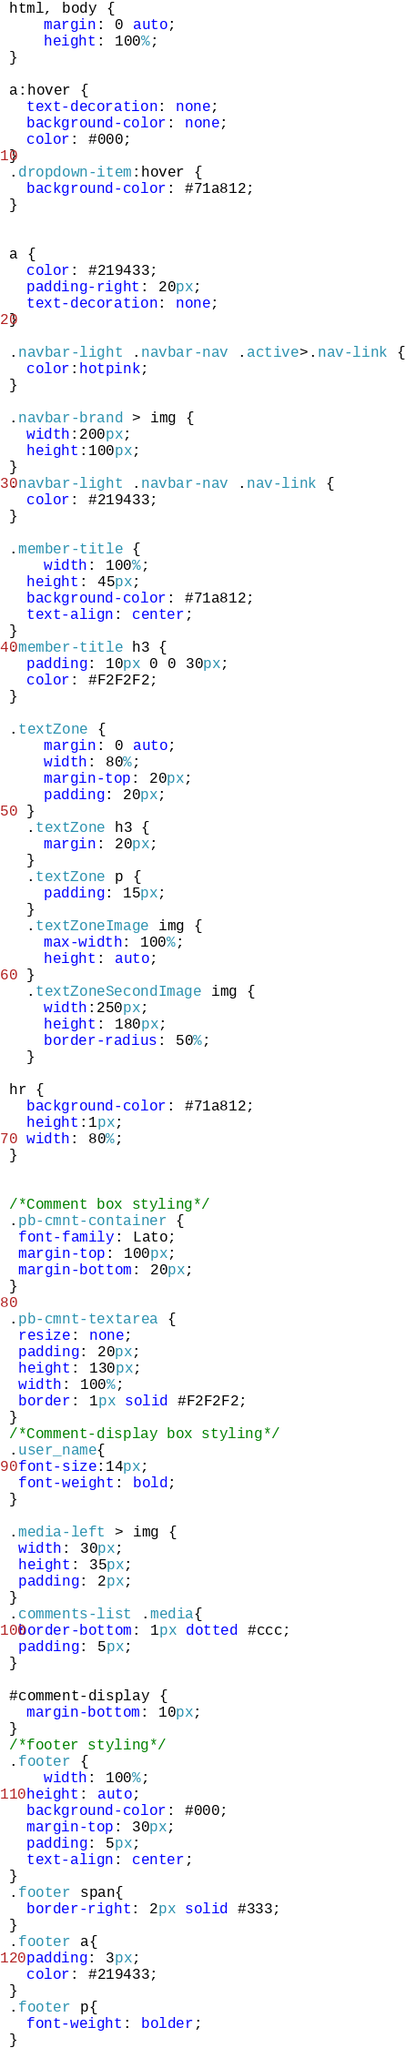Convert code to text. <code><loc_0><loc_0><loc_500><loc_500><_CSS_>

html, body {
    margin: 0 auto;
    height: 100%;
}

a:hover {
  text-decoration: none;
  background-color: none;
  color: #000;
}
.dropdown-item:hover {
  background-color: #71a812;
}


a {
  color: #219433;
  padding-right: 20px;
  text-decoration: none;
}

.navbar-light .navbar-nav .active>.nav-link {
  color:hotpink;
}

.navbar-brand > img {
  width:200px;
  height:100px;
}
.navbar-light .navbar-nav .nav-link {
  color: #219433;
}

.member-title {
	width: 100%;
  height: 45px;
  background-color: #71a812;
  text-align: center;
}
.member-title h3 {
  padding: 10px 0 0 30px;
  color: #F2F2F2;
}

.textZone {
    margin: 0 auto;
    width: 80%;
    margin-top: 20px;
    padding: 20px;
  }
  .textZone h3 {
    margin: 20px;
  }
  .textZone p {
    padding: 15px;
  }
  .textZoneImage img {
    max-width: 100%;
    height: auto;
  }
  .textZoneSecondImage img {
    width:250px;
    height: 180px;
    border-radius: 50%;
  }

hr {
  background-color: #71a812;
  height:1px;
  width: 80%;
}


/*Comment box styling*/
.pb-cmnt-container {
 font-family: Lato;
 margin-top: 100px;
 margin-bottom: 20px;
}

.pb-cmnt-textarea {
 resize: none;
 padding: 20px;
 height: 130px;
 width: 100%;
 border: 1px solid #F2F2F2;
}
/*Comment-display box styling*/
.user_name{
 font-size:14px;
 font-weight: bold;
}

.media-left > img {
 width: 30px;
 height: 35px;
 padding: 2px;
}
.comments-list .media{
 border-bottom: 1px dotted #ccc;
 padding: 5px;
}

#comment-display {
  margin-bottom: 10px;
}
/*footer styling*/
.footer {
	width: 100%;
  height: auto;
  background-color: #000;
  margin-top: 30px;
  padding: 5px;
  text-align: center;
}
.footer span{
  border-right: 2px solid #333;
}
.footer a{
  padding: 3px;
  color: #219433;
}
.footer p{
  font-weight: bolder;
}
</code> 